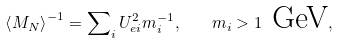<formula> <loc_0><loc_0><loc_500><loc_500>\left \langle M _ { N } \right \rangle ^ { - 1 } = \sum \nolimits _ { i } U _ { e i } ^ { 2 } m _ { i } ^ { - 1 } , \quad m _ { i } > 1 \text { GeV} ,</formula> 